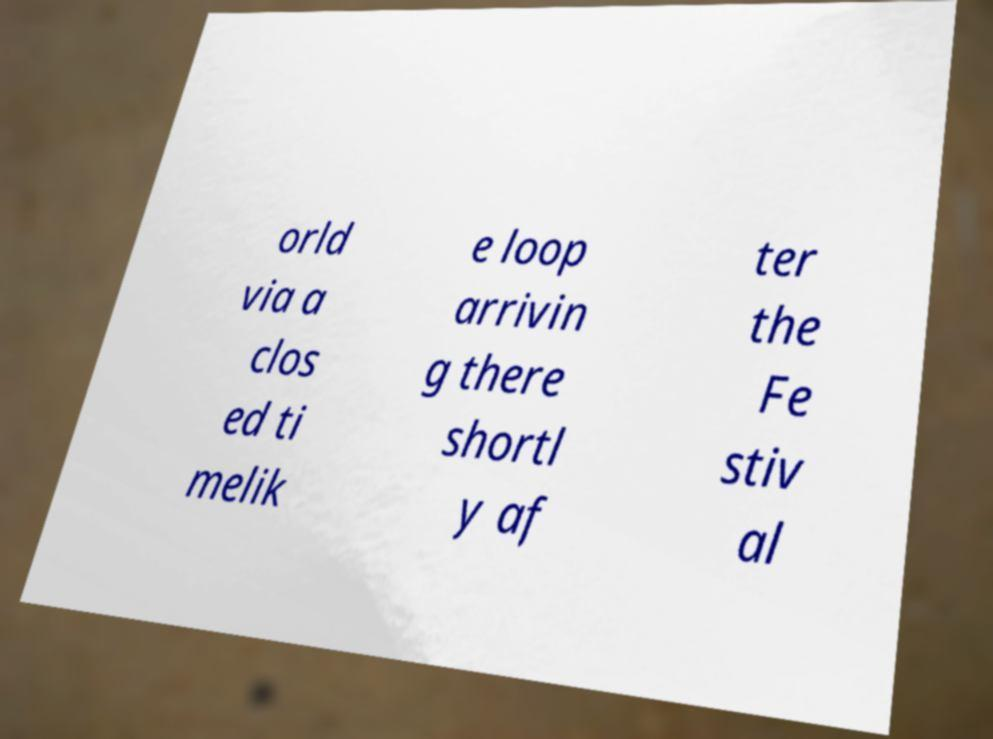There's text embedded in this image that I need extracted. Can you transcribe it verbatim? orld via a clos ed ti melik e loop arrivin g there shortl y af ter the Fe stiv al 